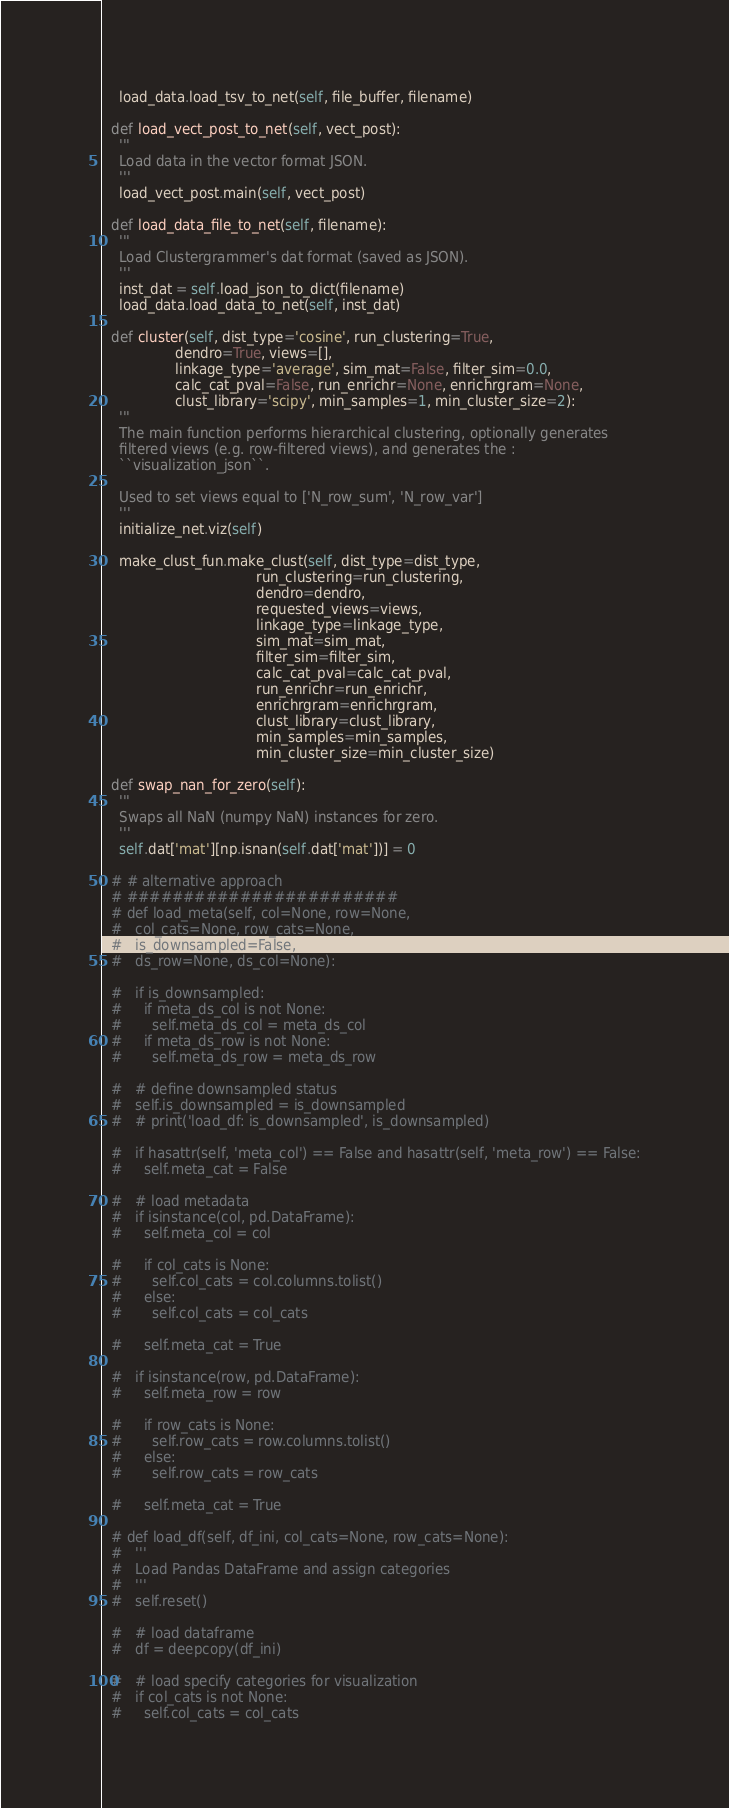<code> <loc_0><loc_0><loc_500><loc_500><_Python_>    load_data.load_tsv_to_net(self, file_buffer, filename)

  def load_vect_post_to_net(self, vect_post):
    '''
    Load data in the vector format JSON.
    '''
    load_vect_post.main(self, vect_post)

  def load_data_file_to_net(self, filename):
    '''
    Load Clustergrammer's dat format (saved as JSON).
    '''
    inst_dat = self.load_json_to_dict(filename)
    load_data.load_data_to_net(self, inst_dat)

  def cluster(self, dist_type='cosine', run_clustering=True,
                 dendro=True, views=[],
                 linkage_type='average', sim_mat=False, filter_sim=0.0,
                 calc_cat_pval=False, run_enrichr=None, enrichrgram=None,
                 clust_library='scipy', min_samples=1, min_cluster_size=2):
    '''
    The main function performs hierarchical clustering, optionally generates
    filtered views (e.g. row-filtered views), and generates the :
    ``visualization_json``.

    Used to set views equal to ['N_row_sum', 'N_row_var']
    '''
    initialize_net.viz(self)

    make_clust_fun.make_clust(self, dist_type=dist_type,
                                    run_clustering=run_clustering,
                                    dendro=dendro,
                                    requested_views=views,
                                    linkage_type=linkage_type,
                                    sim_mat=sim_mat,
                                    filter_sim=filter_sim,
                                    calc_cat_pval=calc_cat_pval,
                                    run_enrichr=run_enrichr,
                                    enrichrgram=enrichrgram,
                                    clust_library=clust_library,
                                    min_samples=min_samples,
                                    min_cluster_size=min_cluster_size)

  def swap_nan_for_zero(self):
    '''
    Swaps all NaN (numpy NaN) instances for zero.
    '''
    self.dat['mat'][np.isnan(self.dat['mat'])] = 0

  # # alternative approach
  # ########################
  # def load_meta(self, col=None, row=None,
  #   col_cats=None, row_cats=None,
  #   is_downsampled=False,
  #   ds_row=None, ds_col=None):

  #   if is_downsampled:
  #     if meta_ds_col is not None:
  #       self.meta_ds_col = meta_ds_col
  #     if meta_ds_row is not None:
  #       self.meta_ds_row = meta_ds_row

  #   # define downsampled status
  #   self.is_downsampled = is_downsampled
  #   # print('load_df: is_downsampled', is_downsampled)

  #   if hasattr(self, 'meta_col') == False and hasattr(self, 'meta_row') == False:
  #     self.meta_cat = False

  #   # load metadata
  #   if isinstance(col, pd.DataFrame):
  #     self.meta_col = col

  #     if col_cats is None:
  #       self.col_cats = col.columns.tolist()
  #     else:
  #       self.col_cats = col_cats

  #     self.meta_cat = True

  #   if isinstance(row, pd.DataFrame):
  #     self.meta_row = row

  #     if row_cats is None:
  #       self.row_cats = row.columns.tolist()
  #     else:
  #       self.row_cats = row_cats

  #     self.meta_cat = True

  # def load_df(self, df_ini, col_cats=None, row_cats=None):
  #   '''
  #   Load Pandas DataFrame and assign categories
  #   '''
  #   self.reset()

  #   # load dataframe
  #   df = deepcopy(df_ini)

  #   # load specify categories for visualization
  #   if col_cats is not None:
  #     self.col_cats = col_cats
</code> 